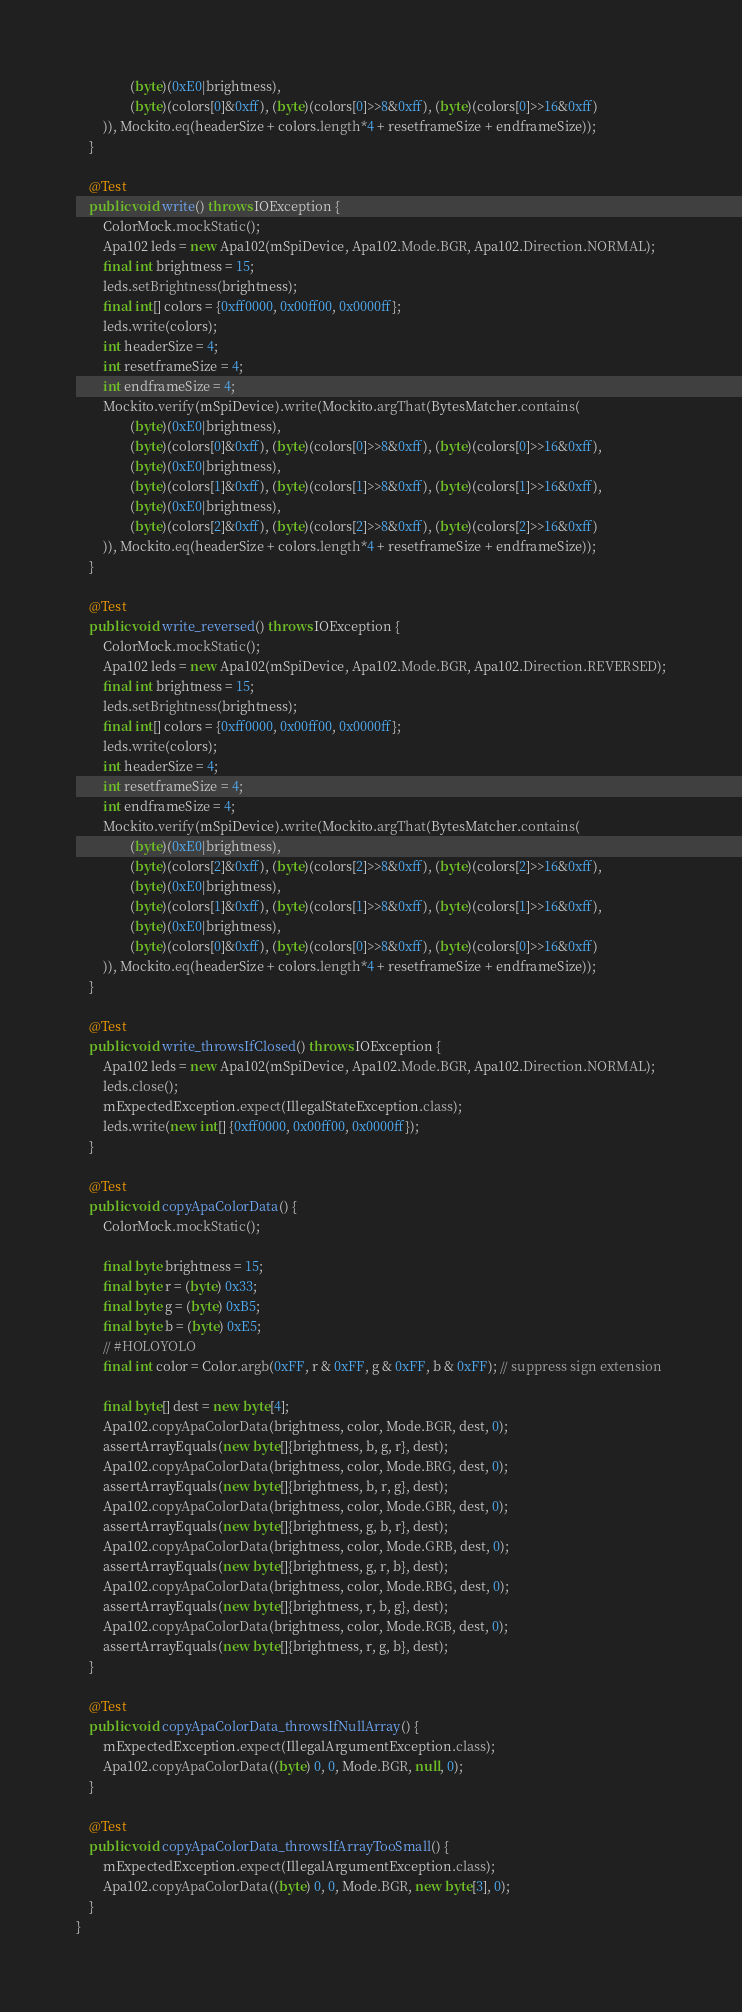<code> <loc_0><loc_0><loc_500><loc_500><_Java_>                (byte)(0xE0|brightness),
                (byte)(colors[0]&0xff), (byte)(colors[0]>>8&0xff), (byte)(colors[0]>>16&0xff)
        )), Mockito.eq(headerSize + colors.length*4 + resetframeSize + endframeSize));
    }

    @Test
    public void write() throws IOException {
        ColorMock.mockStatic();
        Apa102 leds = new Apa102(mSpiDevice, Apa102.Mode.BGR, Apa102.Direction.NORMAL);
        final int brightness = 15;
        leds.setBrightness(brightness);
        final int[] colors = {0xff0000, 0x00ff00, 0x0000ff};
        leds.write(colors);
        int headerSize = 4;
        int resetframeSize = 4;
        int endframeSize = 4;
        Mockito.verify(mSpiDevice).write(Mockito.argThat(BytesMatcher.contains(
                (byte)(0xE0|brightness),
                (byte)(colors[0]&0xff), (byte)(colors[0]>>8&0xff), (byte)(colors[0]>>16&0xff),
                (byte)(0xE0|brightness),
                (byte)(colors[1]&0xff), (byte)(colors[1]>>8&0xff), (byte)(colors[1]>>16&0xff),
                (byte)(0xE0|brightness),
                (byte)(colors[2]&0xff), (byte)(colors[2]>>8&0xff), (byte)(colors[2]>>16&0xff)
        )), Mockito.eq(headerSize + colors.length*4 + resetframeSize + endframeSize));
    }

    @Test
    public void write_reversed() throws IOException {
        ColorMock.mockStatic();
        Apa102 leds = new Apa102(mSpiDevice, Apa102.Mode.BGR, Apa102.Direction.REVERSED);
        final int brightness = 15;
        leds.setBrightness(brightness);
        final int[] colors = {0xff0000, 0x00ff00, 0x0000ff};
        leds.write(colors);
        int headerSize = 4;
        int resetframeSize = 4;
        int endframeSize = 4;
        Mockito.verify(mSpiDevice).write(Mockito.argThat(BytesMatcher.contains(
                (byte)(0xE0|brightness),
                (byte)(colors[2]&0xff), (byte)(colors[2]>>8&0xff), (byte)(colors[2]>>16&0xff),
                (byte)(0xE0|brightness),
                (byte)(colors[1]&0xff), (byte)(colors[1]>>8&0xff), (byte)(colors[1]>>16&0xff),
                (byte)(0xE0|brightness),
                (byte)(colors[0]&0xff), (byte)(colors[0]>>8&0xff), (byte)(colors[0]>>16&0xff)
        )), Mockito.eq(headerSize + colors.length*4 + resetframeSize + endframeSize));
    }

    @Test
    public void write_throwsIfClosed() throws IOException {
        Apa102 leds = new Apa102(mSpiDevice, Apa102.Mode.BGR, Apa102.Direction.NORMAL);
        leds.close();
        mExpectedException.expect(IllegalStateException.class);
        leds.write(new int[] {0xff0000, 0x00ff00, 0x0000ff});
    }

    @Test
    public void copyApaColorData() {
        ColorMock.mockStatic();

        final byte brightness = 15;
        final byte r = (byte) 0x33;
        final byte g = (byte) 0xB5;
        final byte b = (byte) 0xE5;
        // #HOLOYOLO
        final int color = Color.argb(0xFF, r & 0xFF, g & 0xFF, b & 0xFF); // suppress sign extension

        final byte[] dest = new byte[4];
        Apa102.copyApaColorData(brightness, color, Mode.BGR, dest, 0);
        assertArrayEquals(new byte[]{brightness, b, g, r}, dest);
        Apa102.copyApaColorData(brightness, color, Mode.BRG, dest, 0);
        assertArrayEquals(new byte[]{brightness, b, r, g}, dest);
        Apa102.copyApaColorData(brightness, color, Mode.GBR, dest, 0);
        assertArrayEquals(new byte[]{brightness, g, b, r}, dest);
        Apa102.copyApaColorData(brightness, color, Mode.GRB, dest, 0);
        assertArrayEquals(new byte[]{brightness, g, r, b}, dest);
        Apa102.copyApaColorData(brightness, color, Mode.RBG, dest, 0);
        assertArrayEquals(new byte[]{brightness, r, b, g}, dest);
        Apa102.copyApaColorData(brightness, color, Mode.RGB, dest, 0);
        assertArrayEquals(new byte[]{brightness, r, g, b}, dest);
    }

    @Test
    public void copyApaColorData_throwsIfNullArray() {
        mExpectedException.expect(IllegalArgumentException.class);
        Apa102.copyApaColorData((byte) 0, 0, Mode.BGR, null, 0);
    }

    @Test
    public void copyApaColorData_throwsIfArrayTooSmall() {
        mExpectedException.expect(IllegalArgumentException.class);
        Apa102.copyApaColorData((byte) 0, 0, Mode.BGR, new byte[3], 0);
    }
}
</code> 